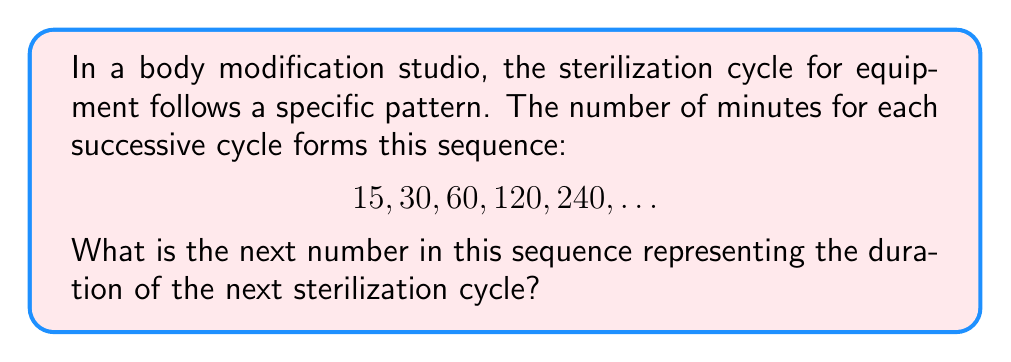Show me your answer to this math problem. To solve this problem, let's analyze the pattern in the given sequence:

1) First, let's look at the relationship between consecutive terms:
   $\frac{30}{15} = 2$
   $\frac{60}{30} = 2$
   $\frac{120}{60} = 2$
   $\frac{240}{120} = 2$

2) We can see that each term is twice the previous term. This is an exponential sequence with a common ratio of 2.

3) We can represent this sequence mathematically as:
   $a_n = 15 \cdot 2^{n-1}$, where $n$ is the position of the term.

4) The given sequence represents the first 5 terms. To find the next (6th) term, we need to calculate $a_6$:

   $a_6 = 15 \cdot 2^{6-1} = 15 \cdot 2^5 = 15 \cdot 32 = 480$

Therefore, the next number in the sequence, representing the duration of the next sterilization cycle, is 480 minutes.
Answer: 480 